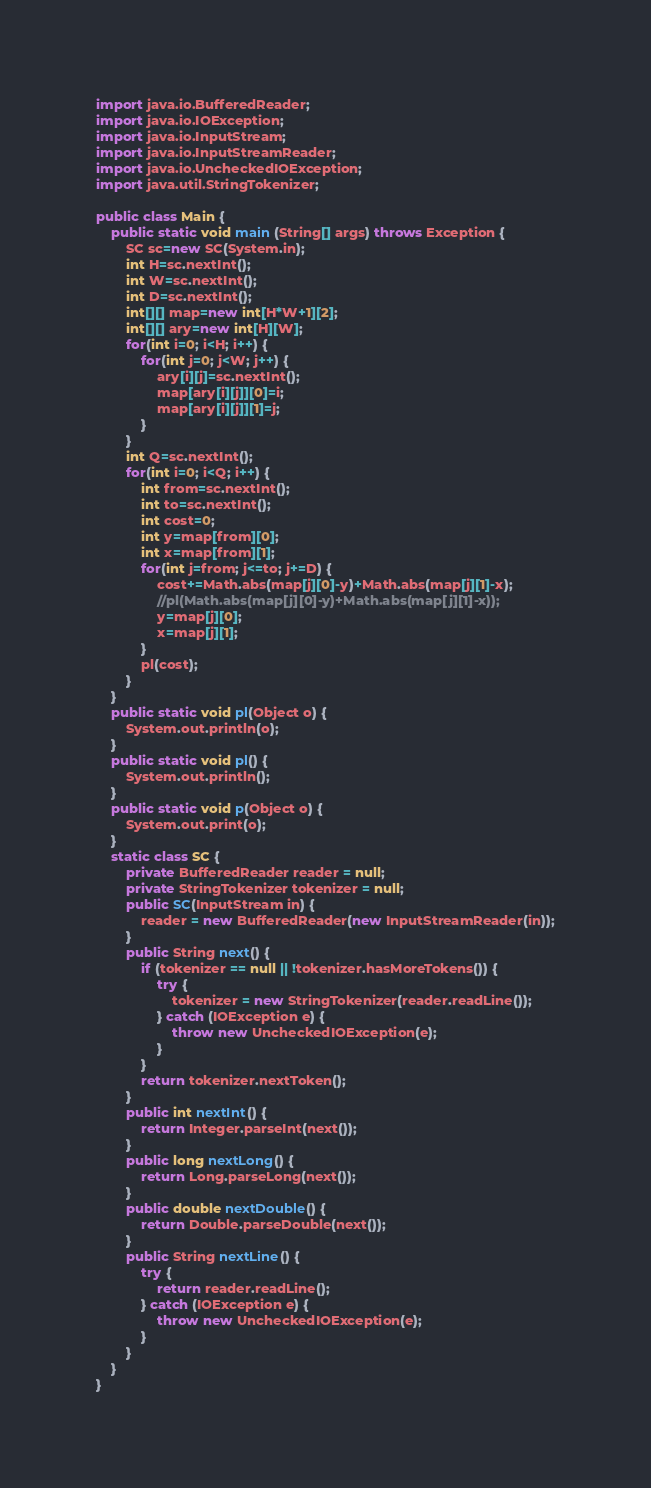<code> <loc_0><loc_0><loc_500><loc_500><_Java_>import java.io.BufferedReader;
import java.io.IOException;
import java.io.InputStream;
import java.io.InputStreamReader;
import java.io.UncheckedIOException;
import java.util.StringTokenizer;

public class Main {
	public static void main (String[] args) throws Exception {
		SC sc=new SC(System.in);
		int H=sc.nextInt();
		int W=sc.nextInt();
		int D=sc.nextInt();
		int[][] map=new int[H*W+1][2];
		int[][] ary=new int[H][W];
		for(int i=0; i<H; i++) {
			for(int j=0; j<W; j++) {
				ary[i][j]=sc.nextInt();
				map[ary[i][j]][0]=i;
				map[ary[i][j]][1]=j;
			}
		}
		int Q=sc.nextInt();
		for(int i=0; i<Q; i++) {
			int from=sc.nextInt();
			int to=sc.nextInt();
			int cost=0;
			int y=map[from][0];
			int x=map[from][1];
			for(int j=from; j<=to; j+=D) {
				cost+=Math.abs(map[j][0]-y)+Math.abs(map[j][1]-x);
				//pl(Math.abs(map[j][0]-y)+Math.abs(map[j][1]-x));
				y=map[j][0];
				x=map[j][1];
			}
			pl(cost);
		}
	}
	public static void pl(Object o) {
		System.out.println(o);
	}
	public static void pl() {
		System.out.println();
	}
	public static void p(Object o) {
		System.out.print(o);
	}
	static class SC {
		private BufferedReader reader = null;
		private StringTokenizer tokenizer = null;
		public SC(InputStream in) {
			reader = new BufferedReader(new InputStreamReader(in));
		}
		public String next() {
			if (tokenizer == null || !tokenizer.hasMoreTokens()) {
				try {
					tokenizer = new StringTokenizer(reader.readLine());
				} catch (IOException e) {
					throw new UncheckedIOException(e);
				}
			}
			return tokenizer.nextToken();
		}
		public int nextInt() {
			return Integer.parseInt(next());
		}
		public long nextLong() {
			return Long.parseLong(next());
		}
		public double nextDouble() {
			return Double.parseDouble(next());
		}
		public String nextLine() {
			try {
				return reader.readLine();
			} catch (IOException e) {
				throw new UncheckedIOException(e);
			}
		}
	}
}
</code> 